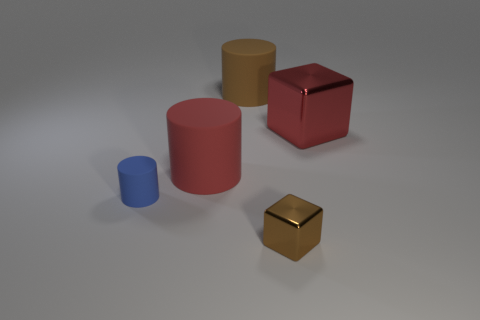How many blue objects have the same size as the red matte object? 0 